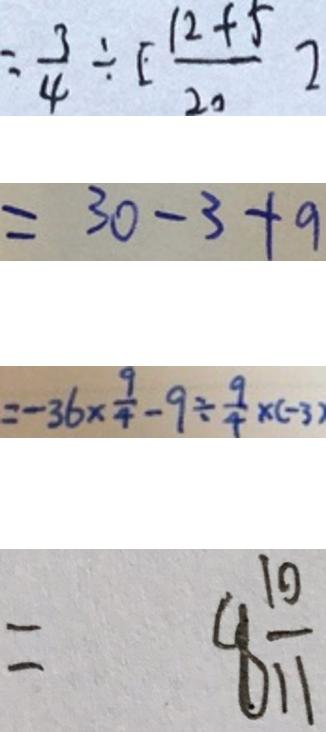<formula> <loc_0><loc_0><loc_500><loc_500>= \frac { 3 } { 4 } \div [ \frac { 1 2 + 5 } { 2 0 } ] 
 = 3 0 - 3 + 9 
 = - 3 6 \times \frac { 9 } { 4 } - 9 \div \frac { 9 } { 4 } \times ( - 3 ) 
 = 8 \frac { 1 0 } { 1 1 }</formula> 